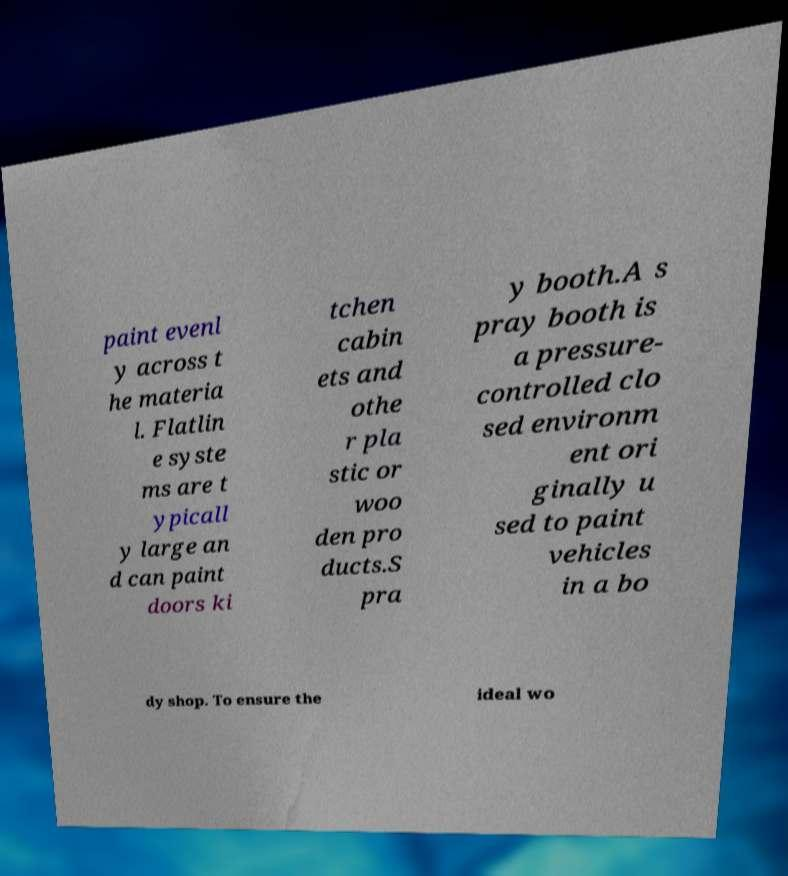Please identify and transcribe the text found in this image. paint evenl y across t he materia l. Flatlin e syste ms are t ypicall y large an d can paint doors ki tchen cabin ets and othe r pla stic or woo den pro ducts.S pra y booth.A s pray booth is a pressure- controlled clo sed environm ent ori ginally u sed to paint vehicles in a bo dy shop. To ensure the ideal wo 